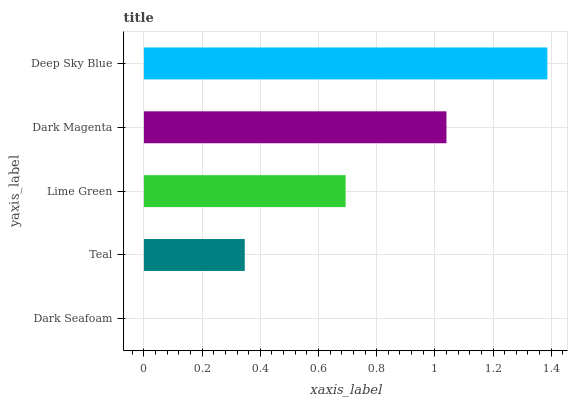Is Dark Seafoam the minimum?
Answer yes or no. Yes. Is Deep Sky Blue the maximum?
Answer yes or no. Yes. Is Teal the minimum?
Answer yes or no. No. Is Teal the maximum?
Answer yes or no. No. Is Teal greater than Dark Seafoam?
Answer yes or no. Yes. Is Dark Seafoam less than Teal?
Answer yes or no. Yes. Is Dark Seafoam greater than Teal?
Answer yes or no. No. Is Teal less than Dark Seafoam?
Answer yes or no. No. Is Lime Green the high median?
Answer yes or no. Yes. Is Lime Green the low median?
Answer yes or no. Yes. Is Deep Sky Blue the high median?
Answer yes or no. No. Is Dark Seafoam the low median?
Answer yes or no. No. 